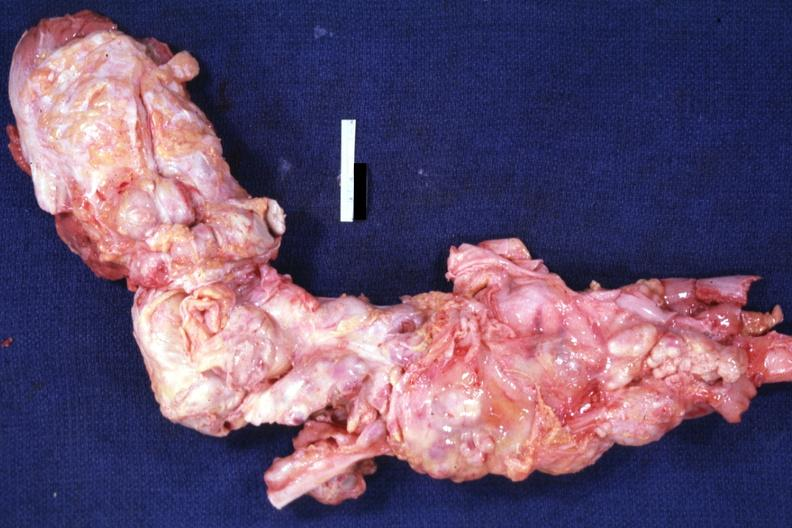what does this image show?
Answer the question using a single word or phrase. Aorta not opened surrounded by large nodes 